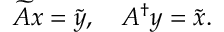Convert formula to latex. <formula><loc_0><loc_0><loc_500><loc_500>\widetilde { A } x = \tilde { y } , \quad A ^ { \dagger } y = \tilde { x } .</formula> 